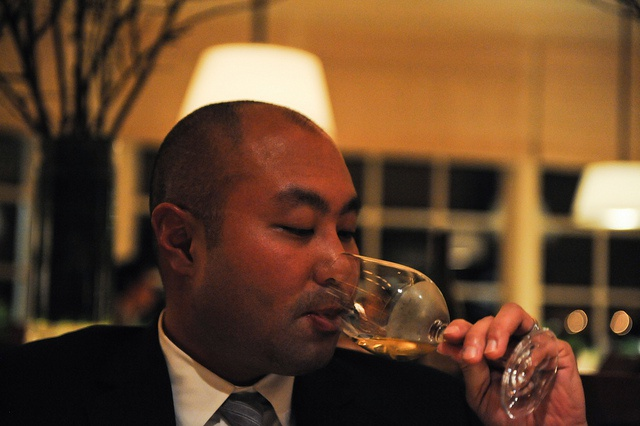Describe the objects in this image and their specific colors. I can see people in black, maroon, brown, and beige tones, wine glass in black, maroon, and brown tones, and tie in black and gray tones in this image. 